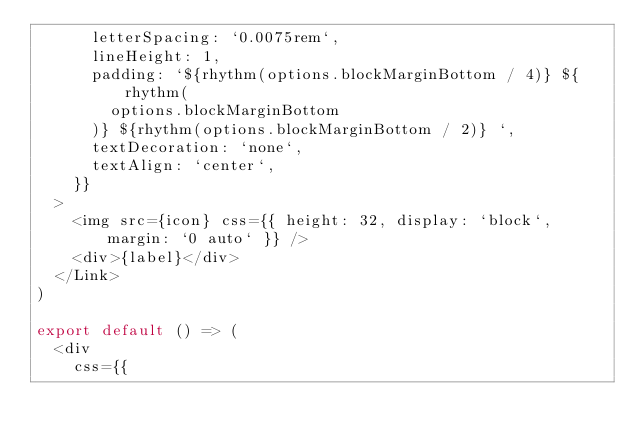<code> <loc_0><loc_0><loc_500><loc_500><_JavaScript_>      letterSpacing: `0.0075rem`,
      lineHeight: 1,
      padding: `${rhythm(options.blockMarginBottom / 4)} ${rhythm(
        options.blockMarginBottom
      )} ${rhythm(options.blockMarginBottom / 2)} `,
      textDecoration: `none`,
      textAlign: `center`,
    }}
  >
    <img src={icon} css={{ height: 32, display: `block`, margin: `0 auto` }} />
    <div>{label}</div>
  </Link>
)

export default () => (
  <div
    css={{</code> 